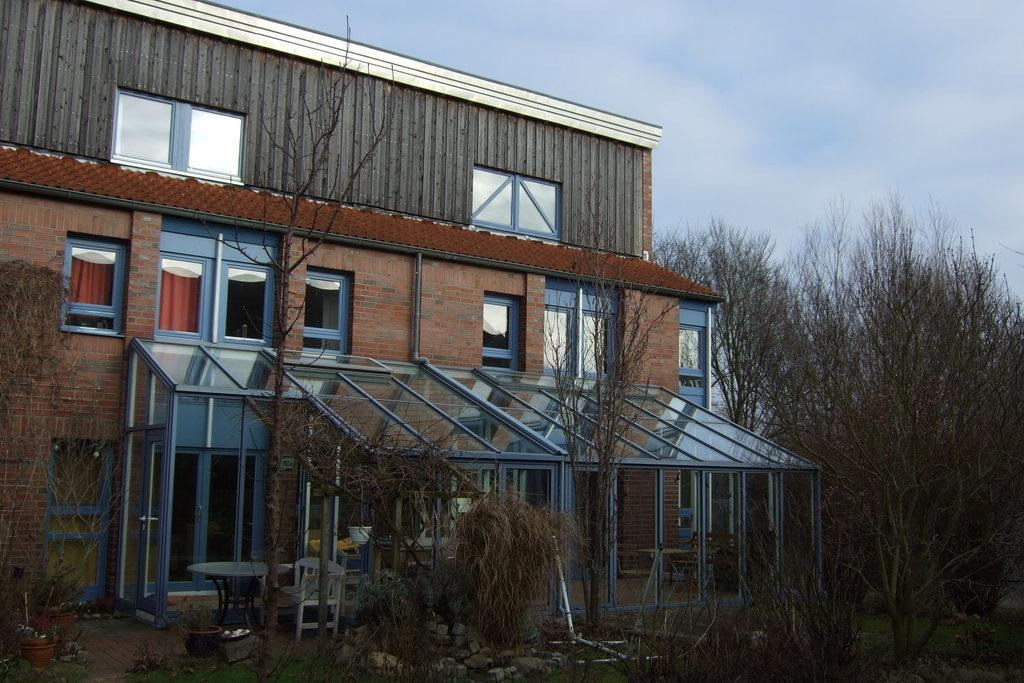What type of natural elements are present in the image? There are plants and trees in the image. What type of man-made structure can be seen in the background? There is a building visible in the background. What part of the natural environment is visible in the image? The sky is visible in the image. What type of furniture is located in the middle of the image? There is a chair in the middle of the image. Where is the lunchroom located in the image? There is no lunchroom present in the image. What type of board is being used by the plants in the image? There is no board present in the image; the plants are growing naturally. 